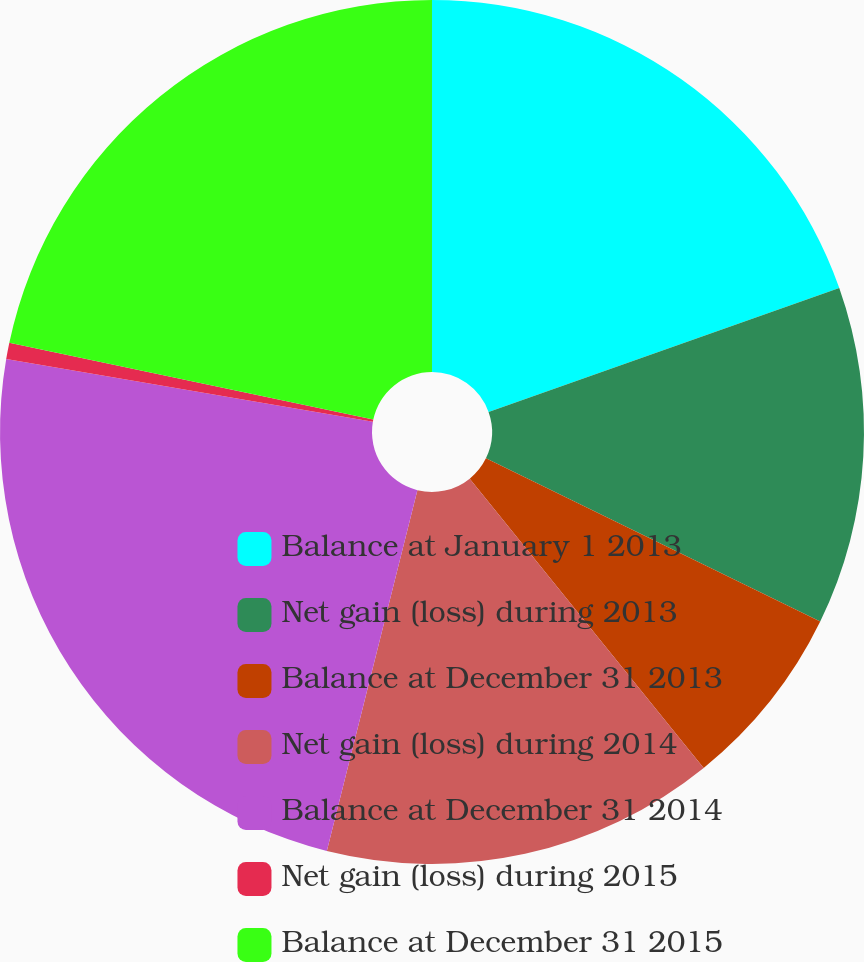<chart> <loc_0><loc_0><loc_500><loc_500><pie_chart><fcel>Balance at January 1 2013<fcel>Net gain (loss) during 2013<fcel>Balance at December 31 2013<fcel>Net gain (loss) during 2014<fcel>Balance at December 31 2014<fcel>Net gain (loss) during 2015<fcel>Balance at December 31 2015<nl><fcel>19.59%<fcel>12.64%<fcel>6.95%<fcel>14.74%<fcel>23.79%<fcel>0.61%<fcel>21.69%<nl></chart> 